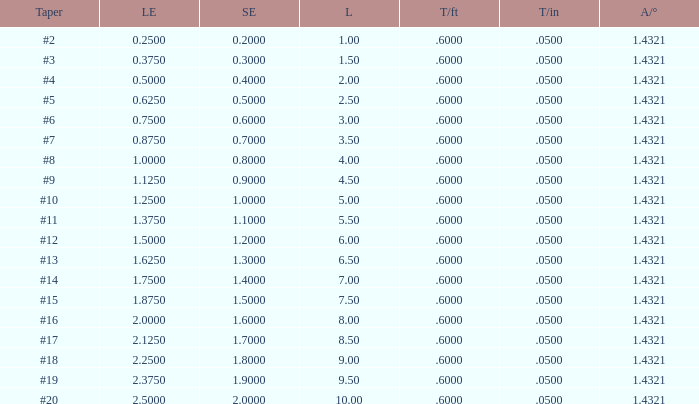Which Length has a Taper of #15, and a Large end larger than 1.875? None. 